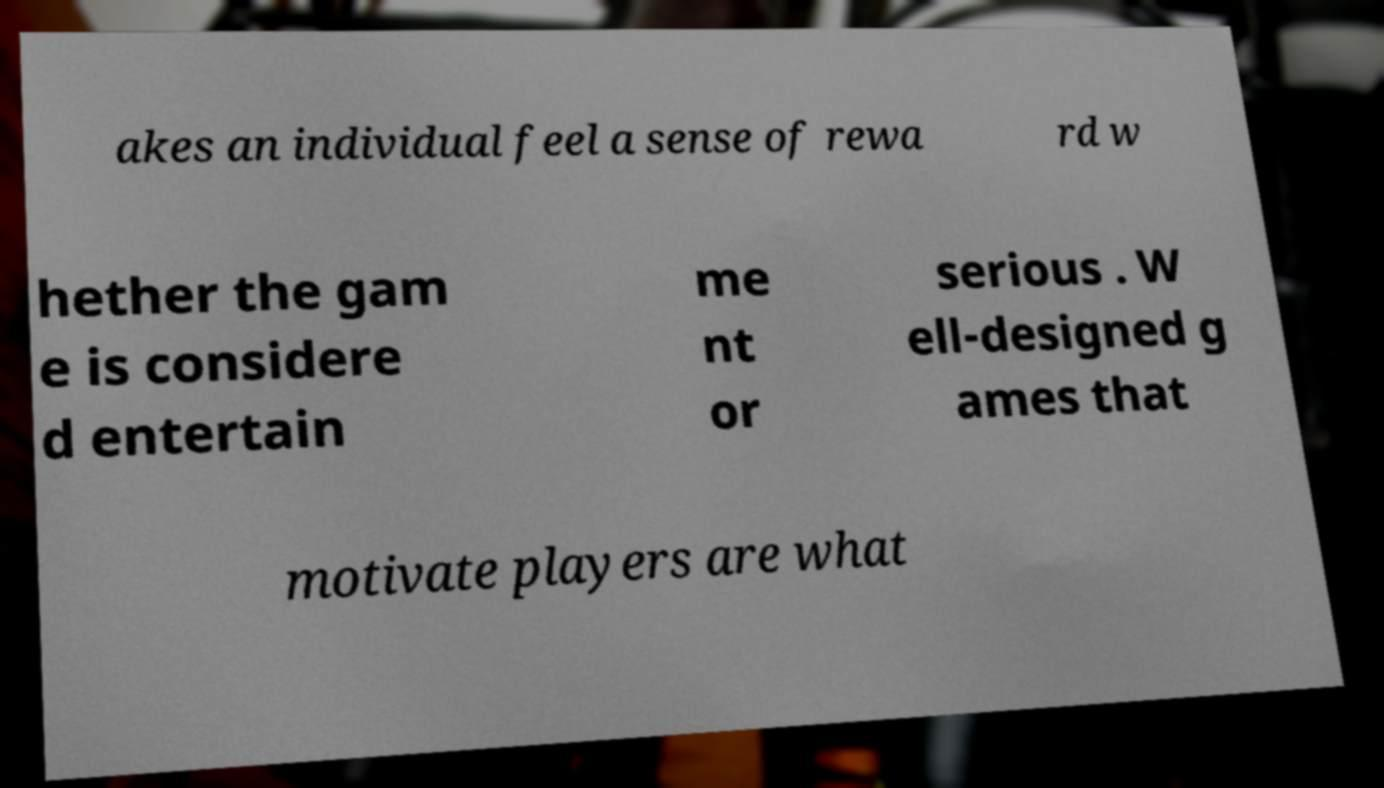There's text embedded in this image that I need extracted. Can you transcribe it verbatim? akes an individual feel a sense of rewa rd w hether the gam e is considere d entertain me nt or serious . W ell-designed g ames that motivate players are what 